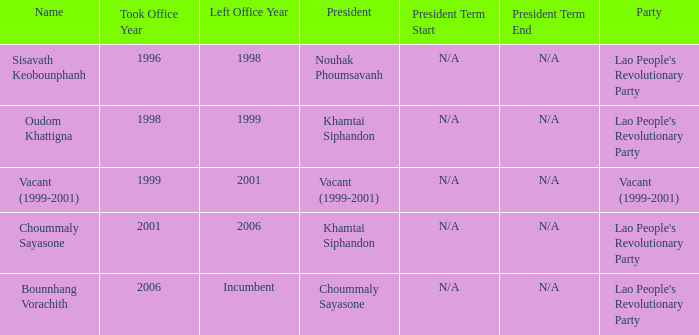What is Left Office, when Party is Vacant (1999-2001)? Vacant (1999-2001). 